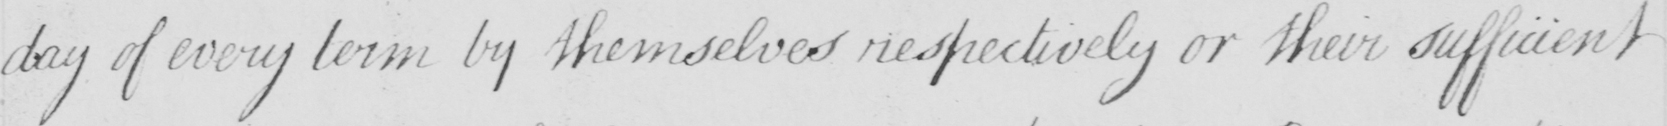What text is written in this handwritten line? day of every term by themselves respectively or their sufficient 